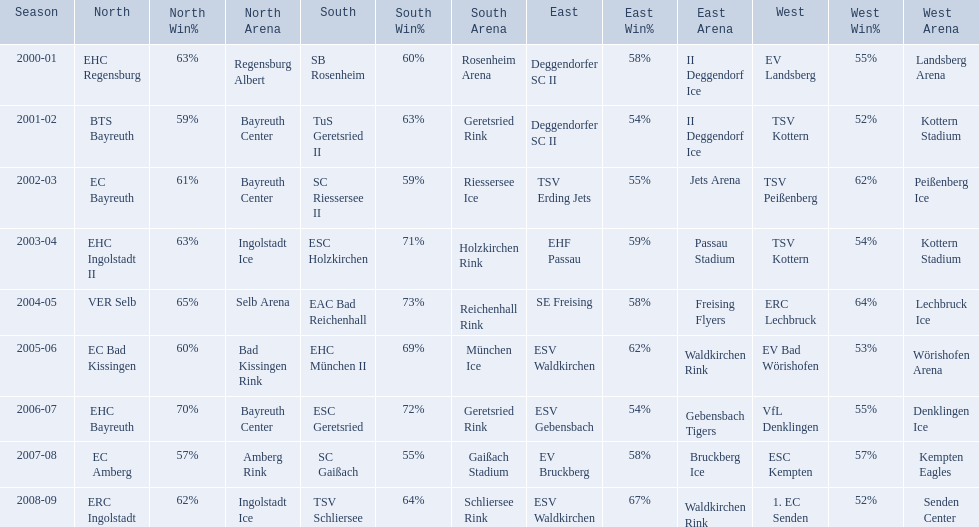Which teams have won in the bavarian ice hockey leagues between 2000 and 2009? EHC Regensburg, SB Rosenheim, Deggendorfer SC II, EV Landsberg, BTS Bayreuth, TuS Geretsried II, TSV Kottern, EC Bayreuth, SC Riessersee II, TSV Erding Jets, TSV Peißenberg, EHC Ingolstadt II, ESC Holzkirchen, EHF Passau, TSV Kottern, VER Selb, EAC Bad Reichenhall, SE Freising, ERC Lechbruck, EC Bad Kissingen, EHC München II, ESV Waldkirchen, EV Bad Wörishofen, EHC Bayreuth, ESC Geretsried, ESV Gebensbach, VfL Denklingen, EC Amberg, SC Gaißach, EV Bruckberg, ESC Kempten, ERC Ingolstadt, TSV Schliersee, ESV Waldkirchen, 1. EC Senden. Which of these winning teams have won the north? EHC Regensburg, BTS Bayreuth, EC Bayreuth, EHC Ingolstadt II, VER Selb, EC Bad Kissingen, EHC Bayreuth, EC Amberg, ERC Ingolstadt. Which of the teams that won the north won in the 2000/2001 season? EHC Regensburg. 